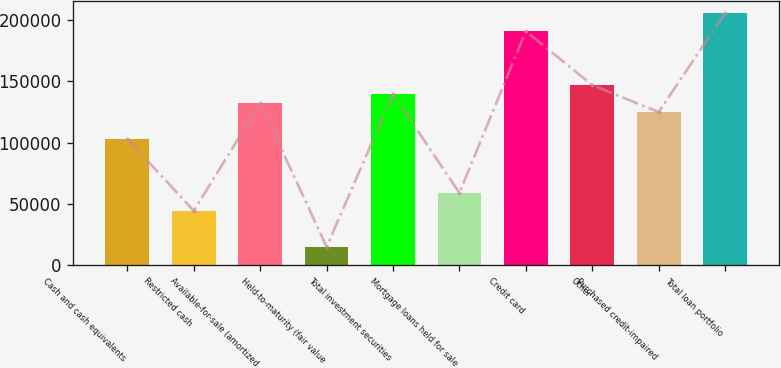Convert chart. <chart><loc_0><loc_0><loc_500><loc_500><bar_chart><fcel>Cash and cash equivalents<fcel>Restricted cash<fcel>Available-for-sale (amortized<fcel>Held-to-maturity (fair value<fcel>Total investment securities<fcel>Mortgage loans held for sale<fcel>Credit card<fcel>Other<fcel>Purchased credit-impaired<fcel>Total loan portfolio<nl><fcel>102885<fcel>44096.6<fcel>132280<fcel>14702.2<fcel>139628<fcel>58793.8<fcel>191069<fcel>146977<fcel>124931<fcel>205766<nl></chart> 